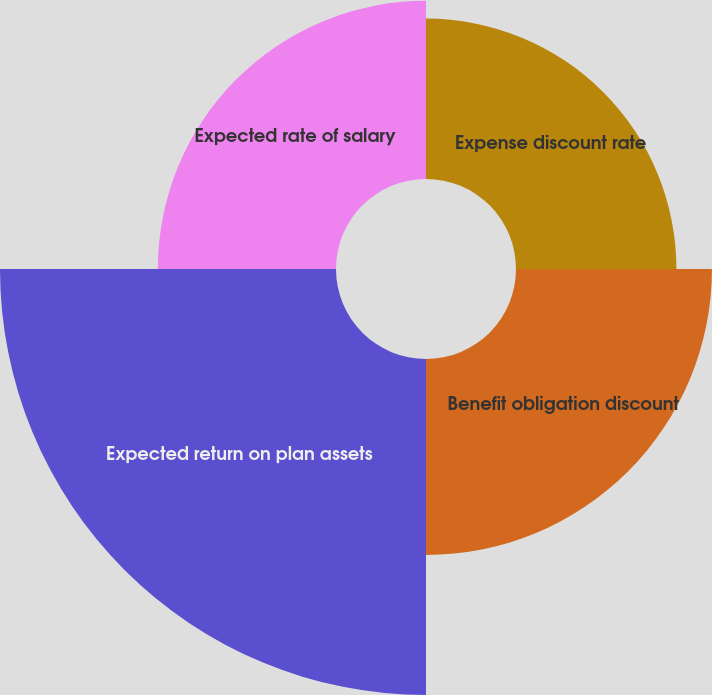<chart> <loc_0><loc_0><loc_500><loc_500><pie_chart><fcel>Expense discount rate<fcel>Benefit obligation discount<fcel>Expected return on plan assets<fcel>Expected rate of salary<nl><fcel>18.43%<fcel>22.51%<fcel>38.6%<fcel>20.47%<nl></chart> 